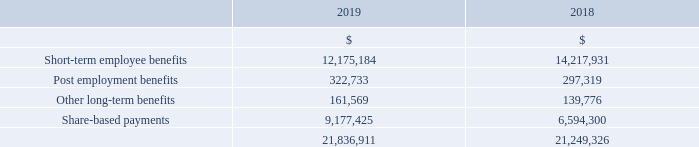This section highlights the Group’s transactions with its related parties, such as its subsidiaries and Key Management Personnel.
During the reporting period and previous reporting periods, Woolworths Group Limited advanced loans to, received and repaid loans from, and provided treasury, accounting, legal, taxation, and administrative services to other entities within the Group.
Entities within the Group also exchanged goods and services in sale and purchase transactions. All transactions occurred on the basis of normal commercial terms and conditions. Balances and transactions between the Company and its subsidiaries, which are related parties of the Company, have been eliminated on consolidation and are not disclosed in this note.
All transactions with directors and Key Management Personnel (including their related parties) were conducted on an arm’s length basis in the ordinary course of business and under normal terms and conditions for customers and employees. Related parties of Key Management Personnel who are employees received normal employee benefits on standard terms and conditions.
The total remuneration for Key Management Personnel of the Group is as follows:
Details of equity instruments provided as compensation to Key Management Personnel and shares issued on exercise of these instruments, together with the terms and conditions of the instruments, are disclosed in the Remuneration Report.
What is the amount of short-term employee benefits in 2018? 14,217,931. What is the total remuneration for Key Management Personnel of the Group in 2019? 21,836,911. How were transactions conducted? On an arm’s length basis in the ordinary course of business and under normal terms and conditions for customers and employees. What is the difference in short-term employee benefits between 2018 and 2019? 14,217,931 - 12,175,184 
Answer: 2042747. What is the average post employment benefits for 2018 and 2019? (322,733 + 297,319)/2 
Answer: 310026. What is the difference in the total remuneration for Key Management Personnel of the Group between 2018 and 2019? 21,836,911 - 21,249,326 
Answer: 587585. 